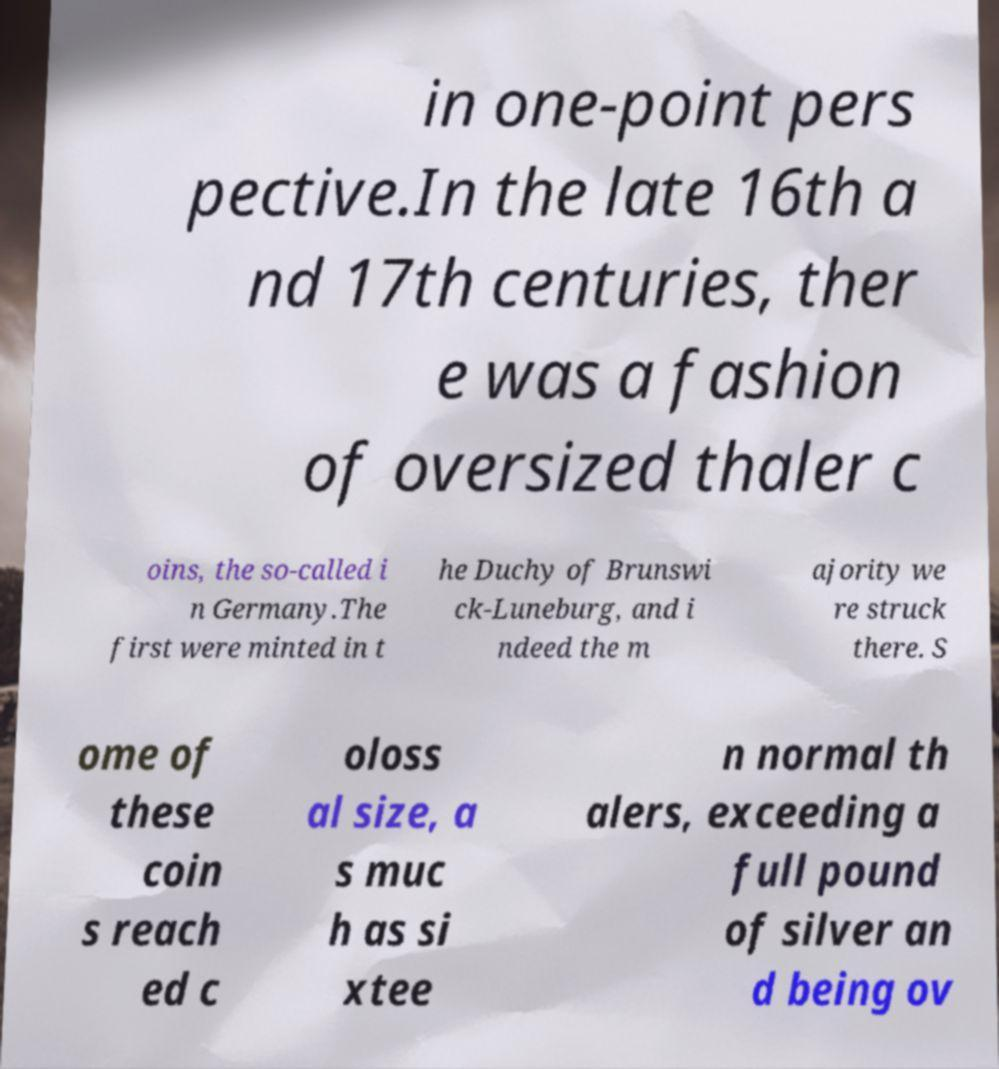Could you extract and type out the text from this image? in one-point pers pective.In the late 16th a nd 17th centuries, ther e was a fashion of oversized thaler c oins, the so-called i n Germany.The first were minted in t he Duchy of Brunswi ck-Luneburg, and i ndeed the m ajority we re struck there. S ome of these coin s reach ed c oloss al size, a s muc h as si xtee n normal th alers, exceeding a full pound of silver an d being ov 